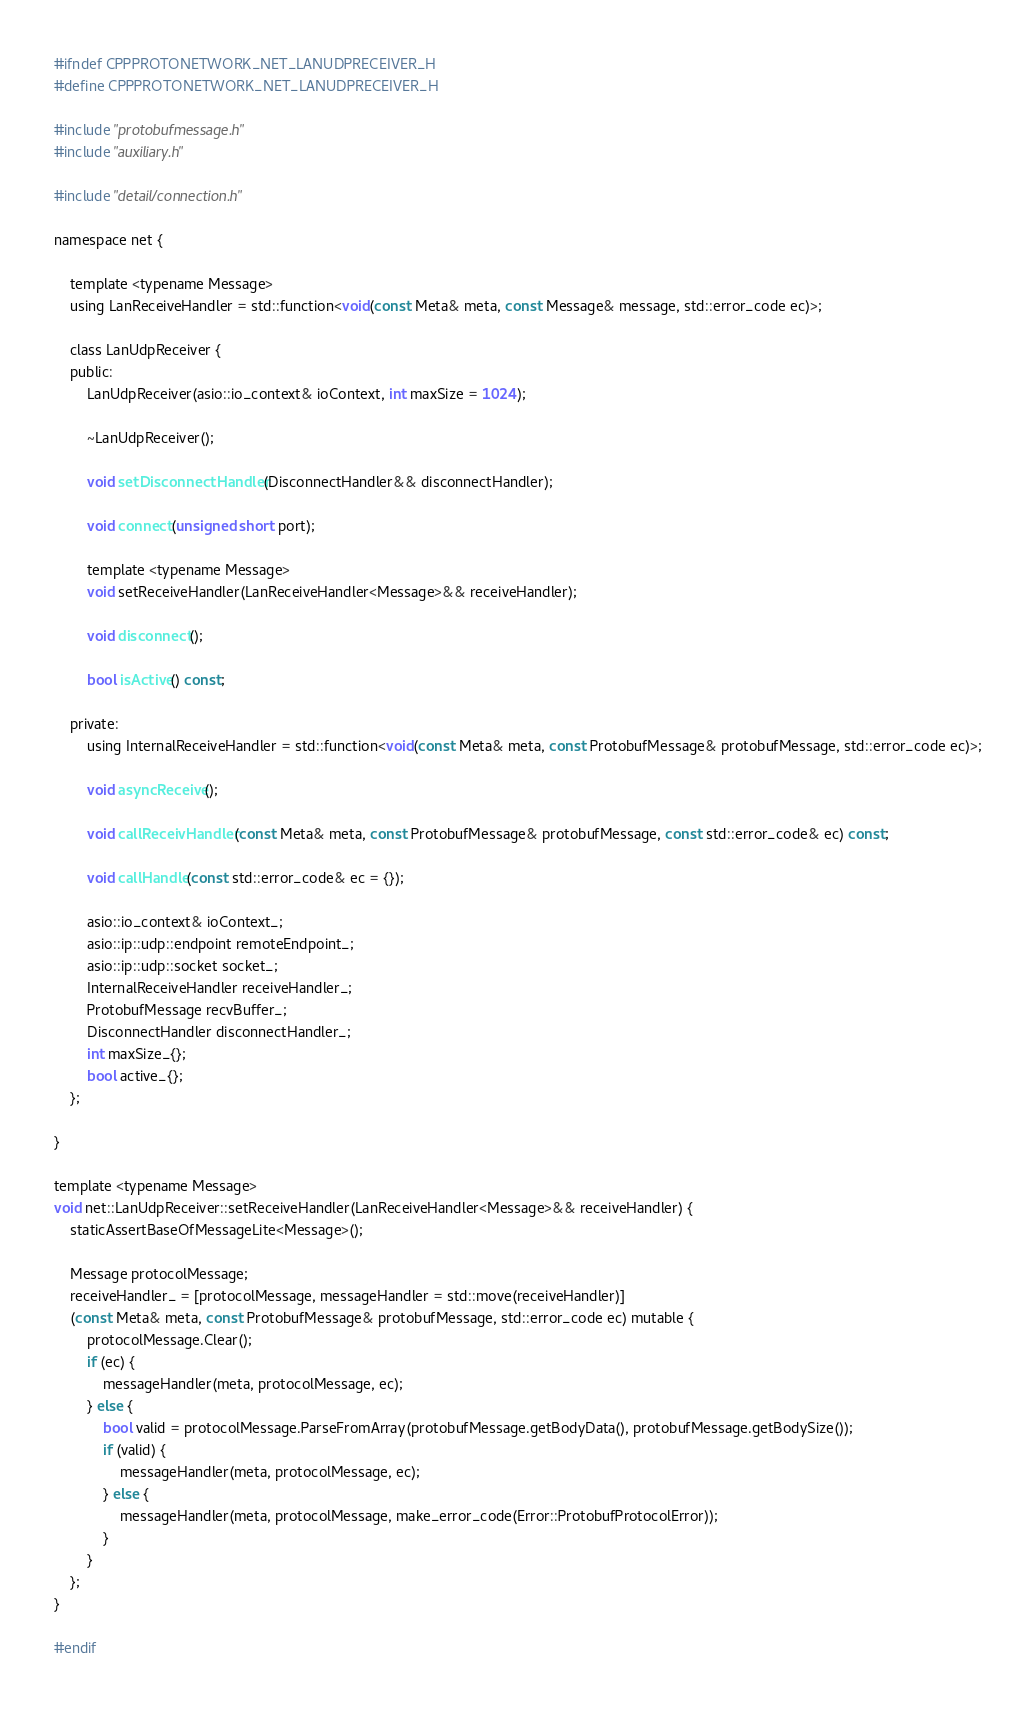<code> <loc_0><loc_0><loc_500><loc_500><_C_>#ifndef CPPPROTONETWORK_NET_LANUDPRECEIVER_H
#define CPPPROTONETWORK_NET_LANUDPRECEIVER_H

#include "protobufmessage.h"
#include "auxiliary.h"

#include "detail/connection.h"

namespace net {

	template <typename Message>
	using LanReceiveHandler = std::function<void(const Meta& meta, const Message& message, std::error_code ec)>;

	class LanUdpReceiver {
	public:
		LanUdpReceiver(asio::io_context& ioContext, int maxSize = 1024);

		~LanUdpReceiver();

		void setDisconnectHandler(DisconnectHandler&& disconnectHandler);

		void connect(unsigned short port);
		
		template <typename Message>
		void setReceiveHandler(LanReceiveHandler<Message>&& receiveHandler);

		void disconnect();

		bool isActive() const;

	private:
		using InternalReceiveHandler = std::function<void(const Meta& meta, const ProtobufMessage& protobufMessage, std::error_code ec)>;

		void asyncReceive();

		void callReceivHandler(const Meta& meta, const ProtobufMessage& protobufMessage, const std::error_code& ec) const;

		void callHandle(const std::error_code& ec = {});
		
		asio::io_context& ioContext_;
		asio::ip::udp::endpoint remoteEndpoint_;
		asio::ip::udp::socket socket_;
		InternalReceiveHandler receiveHandler_;
		ProtobufMessage recvBuffer_;
		DisconnectHandler disconnectHandler_;
		int maxSize_{};
		bool active_{};
	};

}

template <typename Message>
void net::LanUdpReceiver::setReceiveHandler(LanReceiveHandler<Message>&& receiveHandler) {
	staticAssertBaseOfMessageLite<Message>();

	Message protocolMessage;
	receiveHandler_ = [protocolMessage, messageHandler = std::move(receiveHandler)]
	(const Meta& meta, const ProtobufMessage& protobufMessage, std::error_code ec) mutable {
		protocolMessage.Clear();
		if (ec) {
			messageHandler(meta, protocolMessage, ec);
		} else {
			bool valid = protocolMessage.ParseFromArray(protobufMessage.getBodyData(), protobufMessage.getBodySize());
			if (valid) {
				messageHandler(meta, protocolMessage, ec);
			} else {
				messageHandler(meta, protocolMessage, make_error_code(Error::ProtobufProtocolError));
			}
		}
	};
}

#endif
</code> 